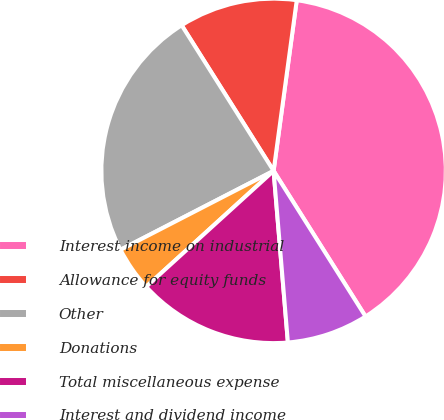Convert chart to OTSL. <chart><loc_0><loc_0><loc_500><loc_500><pie_chart><fcel>Interest income on industrial<fcel>Allowance for equity funds<fcel>Other<fcel>Donations<fcel>Total miscellaneous expense<fcel>Interest and dividend income<nl><fcel>38.89%<fcel>11.11%<fcel>23.61%<fcel>4.17%<fcel>14.58%<fcel>7.64%<nl></chart> 